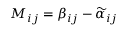<formula> <loc_0><loc_0><loc_500><loc_500>M _ { i j } = \beta _ { i j } - \widetilde { \alpha } _ { i j }</formula> 